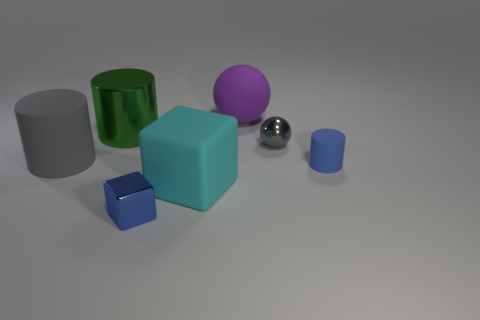What number of things are cyan matte blocks or gray shiny things?
Your answer should be very brief. 2. What number of other objects are there of the same size as the gray ball?
Your answer should be very brief. 2. There is a metallic block; is its color the same as the large cylinder in front of the shiny sphere?
Your answer should be compact. No. What number of blocks are either large purple objects or big green things?
Ensure brevity in your answer.  0. Is there any other thing that is the same color as the big ball?
Keep it short and to the point. No. There is a large object in front of the rubber object that is to the right of the small gray ball; what is its material?
Provide a short and direct response. Rubber. Are the tiny blue cylinder and the tiny blue thing that is on the left side of the blue matte object made of the same material?
Provide a short and direct response. No. What number of objects are objects that are in front of the big gray matte cylinder or large gray matte objects?
Your answer should be very brief. 4. Are there any other spheres that have the same color as the small sphere?
Provide a short and direct response. No. Do the large gray object and the blue object to the right of the purple rubber object have the same shape?
Your answer should be compact. Yes. 